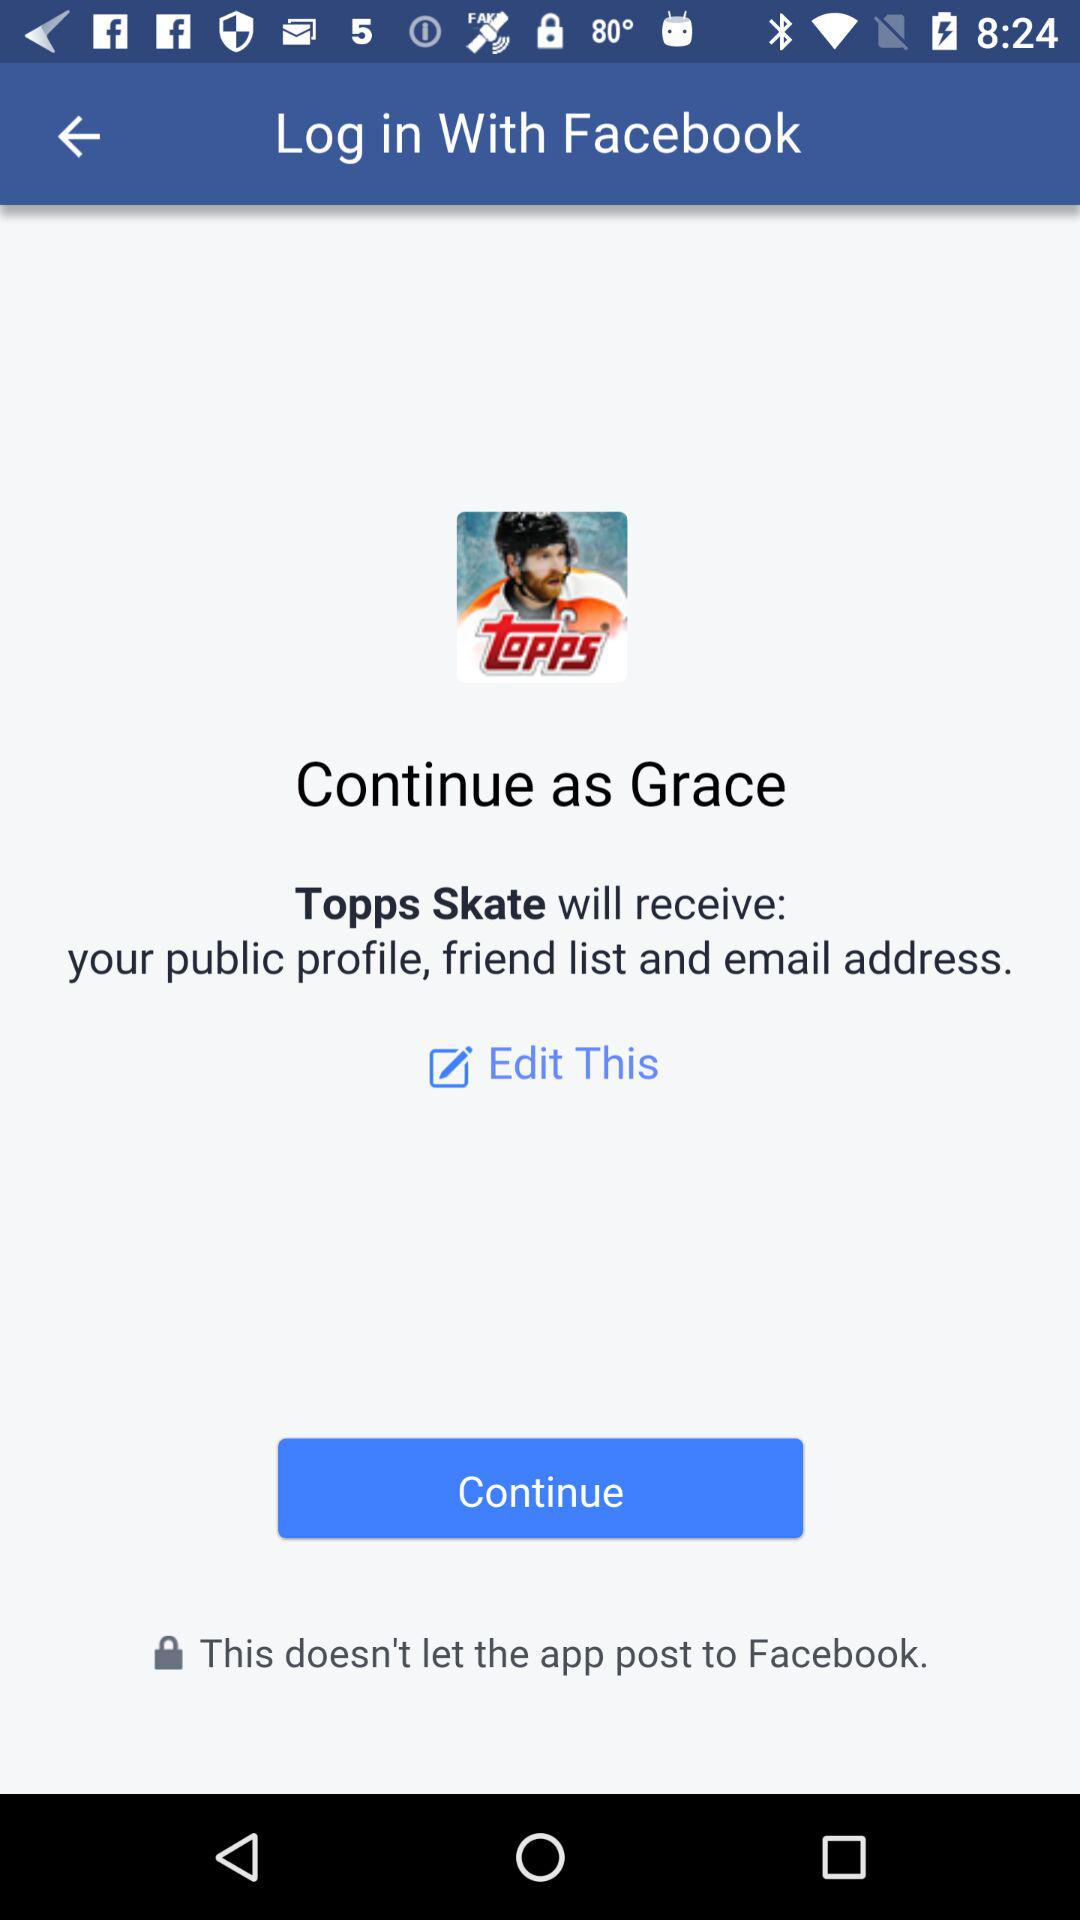Through what application can we log in? You can login through "Facebook". 